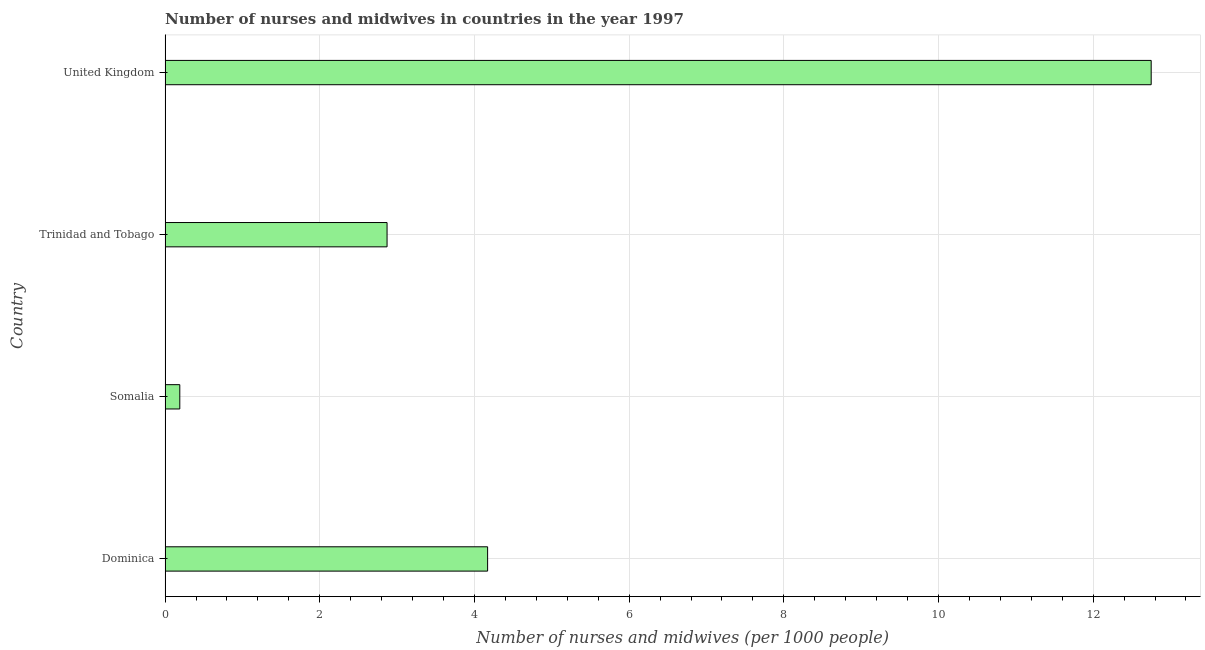Does the graph contain any zero values?
Keep it short and to the point. No. Does the graph contain grids?
Your answer should be compact. Yes. What is the title of the graph?
Ensure brevity in your answer.  Number of nurses and midwives in countries in the year 1997. What is the label or title of the X-axis?
Your answer should be very brief. Number of nurses and midwives (per 1000 people). What is the number of nurses and midwives in United Kingdom?
Provide a short and direct response. 12.75. Across all countries, what is the maximum number of nurses and midwives?
Offer a very short reply. 12.75. Across all countries, what is the minimum number of nurses and midwives?
Your response must be concise. 0.19. In which country was the number of nurses and midwives minimum?
Ensure brevity in your answer.  Somalia. What is the sum of the number of nurses and midwives?
Offer a terse response. 19.98. What is the difference between the number of nurses and midwives in Dominica and United Kingdom?
Offer a very short reply. -8.58. What is the average number of nurses and midwives per country?
Your answer should be compact. 5. What is the median number of nurses and midwives?
Offer a very short reply. 3.52. What is the ratio of the number of nurses and midwives in Dominica to that in Somalia?
Make the answer very short. 21.95. Is the number of nurses and midwives in Trinidad and Tobago less than that in United Kingdom?
Your answer should be very brief. Yes. What is the difference between the highest and the second highest number of nurses and midwives?
Keep it short and to the point. 8.58. Is the sum of the number of nurses and midwives in Trinidad and Tobago and United Kingdom greater than the maximum number of nurses and midwives across all countries?
Your answer should be compact. Yes. What is the difference between the highest and the lowest number of nurses and midwives?
Keep it short and to the point. 12.56. In how many countries, is the number of nurses and midwives greater than the average number of nurses and midwives taken over all countries?
Ensure brevity in your answer.  1. How many bars are there?
Give a very brief answer. 4. What is the difference between two consecutive major ticks on the X-axis?
Make the answer very short. 2. What is the Number of nurses and midwives (per 1000 people) in Dominica?
Give a very brief answer. 4.17. What is the Number of nurses and midwives (per 1000 people) of Somalia?
Offer a very short reply. 0.19. What is the Number of nurses and midwives (per 1000 people) of Trinidad and Tobago?
Give a very brief answer. 2.87. What is the Number of nurses and midwives (per 1000 people) of United Kingdom?
Your answer should be compact. 12.75. What is the difference between the Number of nurses and midwives (per 1000 people) in Dominica and Somalia?
Give a very brief answer. 3.98. What is the difference between the Number of nurses and midwives (per 1000 people) in Dominica and United Kingdom?
Ensure brevity in your answer.  -8.58. What is the difference between the Number of nurses and midwives (per 1000 people) in Somalia and Trinidad and Tobago?
Make the answer very short. -2.68. What is the difference between the Number of nurses and midwives (per 1000 people) in Somalia and United Kingdom?
Your response must be concise. -12.56. What is the difference between the Number of nurses and midwives (per 1000 people) in Trinidad and Tobago and United Kingdom?
Offer a very short reply. -9.88. What is the ratio of the Number of nurses and midwives (per 1000 people) in Dominica to that in Somalia?
Your answer should be compact. 21.95. What is the ratio of the Number of nurses and midwives (per 1000 people) in Dominica to that in Trinidad and Tobago?
Keep it short and to the point. 1.45. What is the ratio of the Number of nurses and midwives (per 1000 people) in Dominica to that in United Kingdom?
Your response must be concise. 0.33. What is the ratio of the Number of nurses and midwives (per 1000 people) in Somalia to that in Trinidad and Tobago?
Offer a very short reply. 0.07. What is the ratio of the Number of nurses and midwives (per 1000 people) in Somalia to that in United Kingdom?
Keep it short and to the point. 0.01. What is the ratio of the Number of nurses and midwives (per 1000 people) in Trinidad and Tobago to that in United Kingdom?
Offer a terse response. 0.23. 